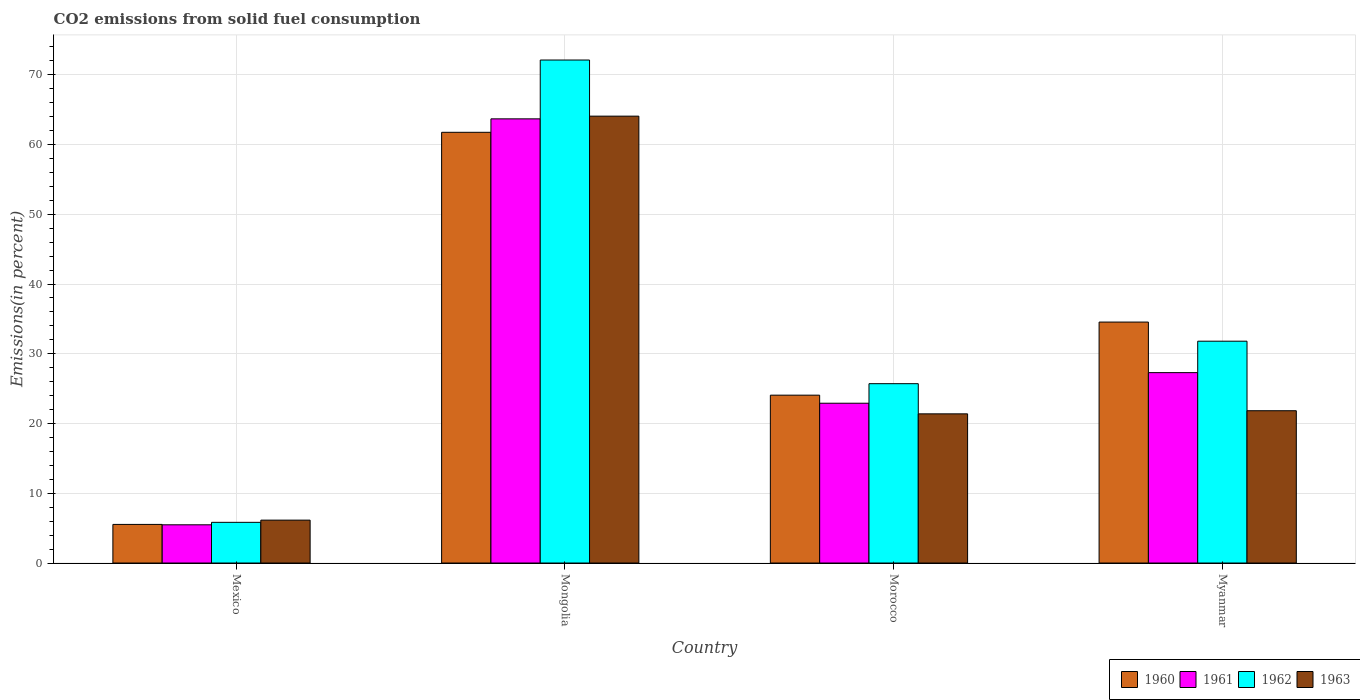Are the number of bars per tick equal to the number of legend labels?
Ensure brevity in your answer.  Yes. Are the number of bars on each tick of the X-axis equal?
Offer a terse response. Yes. How many bars are there on the 2nd tick from the left?
Keep it short and to the point. 4. What is the label of the 4th group of bars from the left?
Provide a succinct answer. Myanmar. What is the total CO2 emitted in 1960 in Mexico?
Provide a succinct answer. 5.54. Across all countries, what is the maximum total CO2 emitted in 1961?
Your answer should be very brief. 63.68. Across all countries, what is the minimum total CO2 emitted in 1961?
Provide a short and direct response. 5.48. In which country was the total CO2 emitted in 1963 maximum?
Ensure brevity in your answer.  Mongolia. In which country was the total CO2 emitted in 1960 minimum?
Ensure brevity in your answer.  Mexico. What is the total total CO2 emitted in 1961 in the graph?
Your response must be concise. 119.38. What is the difference between the total CO2 emitted in 1960 in Mongolia and that in Myanmar?
Provide a short and direct response. 27.21. What is the difference between the total CO2 emitted in 1961 in Mexico and the total CO2 emitted in 1960 in Morocco?
Provide a succinct answer. -18.59. What is the average total CO2 emitted in 1960 per country?
Give a very brief answer. 31.48. What is the difference between the total CO2 emitted of/in 1960 and total CO2 emitted of/in 1963 in Mongolia?
Make the answer very short. -2.32. What is the ratio of the total CO2 emitted in 1962 in Mexico to that in Morocco?
Provide a short and direct response. 0.23. Is the total CO2 emitted in 1960 in Mongolia less than that in Morocco?
Offer a very short reply. No. What is the difference between the highest and the second highest total CO2 emitted in 1963?
Keep it short and to the point. 42.68. What is the difference between the highest and the lowest total CO2 emitted in 1960?
Provide a succinct answer. 56.22. In how many countries, is the total CO2 emitted in 1961 greater than the average total CO2 emitted in 1961 taken over all countries?
Your answer should be compact. 1. Is it the case that in every country, the sum of the total CO2 emitted in 1961 and total CO2 emitted in 1963 is greater than the sum of total CO2 emitted in 1962 and total CO2 emitted in 1960?
Offer a terse response. No. What does the 4th bar from the left in Mongolia represents?
Make the answer very short. 1963. Are all the bars in the graph horizontal?
Keep it short and to the point. No. What is the difference between two consecutive major ticks on the Y-axis?
Your answer should be compact. 10. Does the graph contain any zero values?
Offer a terse response. No. How many legend labels are there?
Make the answer very short. 4. How are the legend labels stacked?
Give a very brief answer. Horizontal. What is the title of the graph?
Provide a succinct answer. CO2 emissions from solid fuel consumption. What is the label or title of the Y-axis?
Provide a short and direct response. Emissions(in percent). What is the Emissions(in percent) of 1960 in Mexico?
Give a very brief answer. 5.54. What is the Emissions(in percent) in 1961 in Mexico?
Your response must be concise. 5.48. What is the Emissions(in percent) of 1962 in Mexico?
Ensure brevity in your answer.  5.83. What is the Emissions(in percent) in 1963 in Mexico?
Provide a short and direct response. 6.15. What is the Emissions(in percent) in 1960 in Mongolia?
Offer a terse response. 61.76. What is the Emissions(in percent) in 1961 in Mongolia?
Keep it short and to the point. 63.68. What is the Emissions(in percent) in 1962 in Mongolia?
Provide a succinct answer. 72.12. What is the Emissions(in percent) in 1963 in Mongolia?
Ensure brevity in your answer.  64.07. What is the Emissions(in percent) in 1960 in Morocco?
Your answer should be compact. 24.07. What is the Emissions(in percent) of 1961 in Morocco?
Your response must be concise. 22.91. What is the Emissions(in percent) of 1962 in Morocco?
Your answer should be compact. 25.71. What is the Emissions(in percent) in 1963 in Morocco?
Your response must be concise. 21.39. What is the Emissions(in percent) in 1960 in Myanmar?
Offer a very short reply. 34.55. What is the Emissions(in percent) in 1961 in Myanmar?
Keep it short and to the point. 27.3. What is the Emissions(in percent) of 1962 in Myanmar?
Make the answer very short. 31.81. What is the Emissions(in percent) in 1963 in Myanmar?
Give a very brief answer. 21.84. Across all countries, what is the maximum Emissions(in percent) in 1960?
Provide a succinct answer. 61.76. Across all countries, what is the maximum Emissions(in percent) in 1961?
Make the answer very short. 63.68. Across all countries, what is the maximum Emissions(in percent) of 1962?
Make the answer very short. 72.12. Across all countries, what is the maximum Emissions(in percent) of 1963?
Offer a terse response. 64.07. Across all countries, what is the minimum Emissions(in percent) of 1960?
Keep it short and to the point. 5.54. Across all countries, what is the minimum Emissions(in percent) in 1961?
Keep it short and to the point. 5.48. Across all countries, what is the minimum Emissions(in percent) in 1962?
Offer a very short reply. 5.83. Across all countries, what is the minimum Emissions(in percent) of 1963?
Ensure brevity in your answer.  6.15. What is the total Emissions(in percent) in 1960 in the graph?
Provide a short and direct response. 125.91. What is the total Emissions(in percent) of 1961 in the graph?
Provide a succinct answer. 119.38. What is the total Emissions(in percent) in 1962 in the graph?
Provide a short and direct response. 135.47. What is the total Emissions(in percent) in 1963 in the graph?
Give a very brief answer. 113.45. What is the difference between the Emissions(in percent) of 1960 in Mexico and that in Mongolia?
Give a very brief answer. -56.22. What is the difference between the Emissions(in percent) in 1961 in Mexico and that in Mongolia?
Give a very brief answer. -58.2. What is the difference between the Emissions(in percent) of 1962 in Mexico and that in Mongolia?
Ensure brevity in your answer.  -66.29. What is the difference between the Emissions(in percent) of 1963 in Mexico and that in Mongolia?
Offer a terse response. -57.92. What is the difference between the Emissions(in percent) of 1960 in Mexico and that in Morocco?
Provide a succinct answer. -18.53. What is the difference between the Emissions(in percent) of 1961 in Mexico and that in Morocco?
Offer a terse response. -17.43. What is the difference between the Emissions(in percent) of 1962 in Mexico and that in Morocco?
Make the answer very short. -19.88. What is the difference between the Emissions(in percent) in 1963 in Mexico and that in Morocco?
Provide a succinct answer. -15.24. What is the difference between the Emissions(in percent) of 1960 in Mexico and that in Myanmar?
Offer a very short reply. -29.01. What is the difference between the Emissions(in percent) in 1961 in Mexico and that in Myanmar?
Give a very brief answer. -21.82. What is the difference between the Emissions(in percent) in 1962 in Mexico and that in Myanmar?
Offer a terse response. -25.97. What is the difference between the Emissions(in percent) of 1963 in Mexico and that in Myanmar?
Give a very brief answer. -15.69. What is the difference between the Emissions(in percent) in 1960 in Mongolia and that in Morocco?
Your response must be concise. 37.69. What is the difference between the Emissions(in percent) in 1961 in Mongolia and that in Morocco?
Keep it short and to the point. 40.77. What is the difference between the Emissions(in percent) of 1962 in Mongolia and that in Morocco?
Your answer should be compact. 46.4. What is the difference between the Emissions(in percent) in 1963 in Mongolia and that in Morocco?
Give a very brief answer. 42.68. What is the difference between the Emissions(in percent) in 1960 in Mongolia and that in Myanmar?
Provide a short and direct response. 27.21. What is the difference between the Emissions(in percent) in 1961 in Mongolia and that in Myanmar?
Make the answer very short. 36.39. What is the difference between the Emissions(in percent) in 1962 in Mongolia and that in Myanmar?
Keep it short and to the point. 40.31. What is the difference between the Emissions(in percent) of 1963 in Mongolia and that in Myanmar?
Offer a very short reply. 42.24. What is the difference between the Emissions(in percent) of 1960 in Morocco and that in Myanmar?
Make the answer very short. -10.48. What is the difference between the Emissions(in percent) of 1961 in Morocco and that in Myanmar?
Your answer should be very brief. -4.39. What is the difference between the Emissions(in percent) in 1962 in Morocco and that in Myanmar?
Provide a succinct answer. -6.09. What is the difference between the Emissions(in percent) in 1963 in Morocco and that in Myanmar?
Your answer should be compact. -0.45. What is the difference between the Emissions(in percent) in 1960 in Mexico and the Emissions(in percent) in 1961 in Mongolia?
Make the answer very short. -58.15. What is the difference between the Emissions(in percent) of 1960 in Mexico and the Emissions(in percent) of 1962 in Mongolia?
Keep it short and to the point. -66.58. What is the difference between the Emissions(in percent) of 1960 in Mexico and the Emissions(in percent) of 1963 in Mongolia?
Offer a very short reply. -58.54. What is the difference between the Emissions(in percent) in 1961 in Mexico and the Emissions(in percent) in 1962 in Mongolia?
Offer a very short reply. -66.64. What is the difference between the Emissions(in percent) of 1961 in Mexico and the Emissions(in percent) of 1963 in Mongolia?
Offer a very short reply. -58.59. What is the difference between the Emissions(in percent) in 1962 in Mexico and the Emissions(in percent) in 1963 in Mongolia?
Your response must be concise. -58.24. What is the difference between the Emissions(in percent) of 1960 in Mexico and the Emissions(in percent) of 1961 in Morocco?
Your answer should be compact. -17.38. What is the difference between the Emissions(in percent) in 1960 in Mexico and the Emissions(in percent) in 1962 in Morocco?
Ensure brevity in your answer.  -20.18. What is the difference between the Emissions(in percent) of 1960 in Mexico and the Emissions(in percent) of 1963 in Morocco?
Give a very brief answer. -15.85. What is the difference between the Emissions(in percent) in 1961 in Mexico and the Emissions(in percent) in 1962 in Morocco?
Make the answer very short. -20.23. What is the difference between the Emissions(in percent) of 1961 in Mexico and the Emissions(in percent) of 1963 in Morocco?
Give a very brief answer. -15.91. What is the difference between the Emissions(in percent) in 1962 in Mexico and the Emissions(in percent) in 1963 in Morocco?
Offer a very short reply. -15.56. What is the difference between the Emissions(in percent) of 1960 in Mexico and the Emissions(in percent) of 1961 in Myanmar?
Make the answer very short. -21.76. What is the difference between the Emissions(in percent) of 1960 in Mexico and the Emissions(in percent) of 1962 in Myanmar?
Provide a short and direct response. -26.27. What is the difference between the Emissions(in percent) in 1960 in Mexico and the Emissions(in percent) in 1963 in Myanmar?
Keep it short and to the point. -16.3. What is the difference between the Emissions(in percent) in 1961 in Mexico and the Emissions(in percent) in 1962 in Myanmar?
Your answer should be very brief. -26.33. What is the difference between the Emissions(in percent) in 1961 in Mexico and the Emissions(in percent) in 1963 in Myanmar?
Make the answer very short. -16.36. What is the difference between the Emissions(in percent) in 1962 in Mexico and the Emissions(in percent) in 1963 in Myanmar?
Provide a succinct answer. -16. What is the difference between the Emissions(in percent) in 1960 in Mongolia and the Emissions(in percent) in 1961 in Morocco?
Your response must be concise. 38.84. What is the difference between the Emissions(in percent) in 1960 in Mongolia and the Emissions(in percent) in 1962 in Morocco?
Offer a very short reply. 36.04. What is the difference between the Emissions(in percent) in 1960 in Mongolia and the Emissions(in percent) in 1963 in Morocco?
Offer a terse response. 40.37. What is the difference between the Emissions(in percent) in 1961 in Mongolia and the Emissions(in percent) in 1962 in Morocco?
Ensure brevity in your answer.  37.97. What is the difference between the Emissions(in percent) of 1961 in Mongolia and the Emissions(in percent) of 1963 in Morocco?
Offer a terse response. 42.3. What is the difference between the Emissions(in percent) of 1962 in Mongolia and the Emissions(in percent) of 1963 in Morocco?
Keep it short and to the point. 50.73. What is the difference between the Emissions(in percent) in 1960 in Mongolia and the Emissions(in percent) in 1961 in Myanmar?
Ensure brevity in your answer.  34.46. What is the difference between the Emissions(in percent) in 1960 in Mongolia and the Emissions(in percent) in 1962 in Myanmar?
Offer a very short reply. 29.95. What is the difference between the Emissions(in percent) in 1960 in Mongolia and the Emissions(in percent) in 1963 in Myanmar?
Your answer should be very brief. 39.92. What is the difference between the Emissions(in percent) in 1961 in Mongolia and the Emissions(in percent) in 1962 in Myanmar?
Provide a short and direct response. 31.88. What is the difference between the Emissions(in percent) in 1961 in Mongolia and the Emissions(in percent) in 1963 in Myanmar?
Provide a succinct answer. 41.85. What is the difference between the Emissions(in percent) in 1962 in Mongolia and the Emissions(in percent) in 1963 in Myanmar?
Keep it short and to the point. 50.28. What is the difference between the Emissions(in percent) of 1960 in Morocco and the Emissions(in percent) of 1961 in Myanmar?
Your answer should be compact. -3.23. What is the difference between the Emissions(in percent) in 1960 in Morocco and the Emissions(in percent) in 1962 in Myanmar?
Keep it short and to the point. -7.74. What is the difference between the Emissions(in percent) in 1960 in Morocco and the Emissions(in percent) in 1963 in Myanmar?
Your answer should be compact. 2.23. What is the difference between the Emissions(in percent) of 1961 in Morocco and the Emissions(in percent) of 1962 in Myanmar?
Your answer should be very brief. -8.89. What is the difference between the Emissions(in percent) in 1961 in Morocco and the Emissions(in percent) in 1963 in Myanmar?
Provide a succinct answer. 1.08. What is the difference between the Emissions(in percent) in 1962 in Morocco and the Emissions(in percent) in 1963 in Myanmar?
Your answer should be very brief. 3.88. What is the average Emissions(in percent) in 1960 per country?
Provide a succinct answer. 31.48. What is the average Emissions(in percent) in 1961 per country?
Offer a very short reply. 29.84. What is the average Emissions(in percent) of 1962 per country?
Your response must be concise. 33.87. What is the average Emissions(in percent) of 1963 per country?
Give a very brief answer. 28.36. What is the difference between the Emissions(in percent) of 1960 and Emissions(in percent) of 1961 in Mexico?
Provide a succinct answer. 0.06. What is the difference between the Emissions(in percent) of 1960 and Emissions(in percent) of 1962 in Mexico?
Your answer should be very brief. -0.3. What is the difference between the Emissions(in percent) of 1960 and Emissions(in percent) of 1963 in Mexico?
Ensure brevity in your answer.  -0.61. What is the difference between the Emissions(in percent) of 1961 and Emissions(in percent) of 1962 in Mexico?
Ensure brevity in your answer.  -0.35. What is the difference between the Emissions(in percent) in 1961 and Emissions(in percent) in 1963 in Mexico?
Your answer should be very brief. -0.67. What is the difference between the Emissions(in percent) in 1962 and Emissions(in percent) in 1963 in Mexico?
Offer a very short reply. -0.32. What is the difference between the Emissions(in percent) of 1960 and Emissions(in percent) of 1961 in Mongolia?
Offer a very short reply. -1.93. What is the difference between the Emissions(in percent) of 1960 and Emissions(in percent) of 1962 in Mongolia?
Ensure brevity in your answer.  -10.36. What is the difference between the Emissions(in percent) in 1960 and Emissions(in percent) in 1963 in Mongolia?
Provide a succinct answer. -2.32. What is the difference between the Emissions(in percent) of 1961 and Emissions(in percent) of 1962 in Mongolia?
Your answer should be very brief. -8.43. What is the difference between the Emissions(in percent) in 1961 and Emissions(in percent) in 1963 in Mongolia?
Offer a very short reply. -0.39. What is the difference between the Emissions(in percent) in 1962 and Emissions(in percent) in 1963 in Mongolia?
Ensure brevity in your answer.  8.05. What is the difference between the Emissions(in percent) of 1960 and Emissions(in percent) of 1961 in Morocco?
Your answer should be compact. 1.16. What is the difference between the Emissions(in percent) in 1960 and Emissions(in percent) in 1962 in Morocco?
Ensure brevity in your answer.  -1.65. What is the difference between the Emissions(in percent) of 1960 and Emissions(in percent) of 1963 in Morocco?
Offer a terse response. 2.68. What is the difference between the Emissions(in percent) of 1961 and Emissions(in percent) of 1962 in Morocco?
Give a very brief answer. -2.8. What is the difference between the Emissions(in percent) of 1961 and Emissions(in percent) of 1963 in Morocco?
Provide a short and direct response. 1.52. What is the difference between the Emissions(in percent) in 1962 and Emissions(in percent) in 1963 in Morocco?
Make the answer very short. 4.33. What is the difference between the Emissions(in percent) of 1960 and Emissions(in percent) of 1961 in Myanmar?
Keep it short and to the point. 7.25. What is the difference between the Emissions(in percent) of 1960 and Emissions(in percent) of 1962 in Myanmar?
Offer a terse response. 2.74. What is the difference between the Emissions(in percent) of 1960 and Emissions(in percent) of 1963 in Myanmar?
Offer a terse response. 12.71. What is the difference between the Emissions(in percent) in 1961 and Emissions(in percent) in 1962 in Myanmar?
Keep it short and to the point. -4.51. What is the difference between the Emissions(in percent) of 1961 and Emissions(in percent) of 1963 in Myanmar?
Give a very brief answer. 5.46. What is the difference between the Emissions(in percent) in 1962 and Emissions(in percent) in 1963 in Myanmar?
Your answer should be compact. 9.97. What is the ratio of the Emissions(in percent) in 1960 in Mexico to that in Mongolia?
Your response must be concise. 0.09. What is the ratio of the Emissions(in percent) in 1961 in Mexico to that in Mongolia?
Your response must be concise. 0.09. What is the ratio of the Emissions(in percent) in 1962 in Mexico to that in Mongolia?
Give a very brief answer. 0.08. What is the ratio of the Emissions(in percent) of 1963 in Mexico to that in Mongolia?
Offer a terse response. 0.1. What is the ratio of the Emissions(in percent) in 1960 in Mexico to that in Morocco?
Offer a very short reply. 0.23. What is the ratio of the Emissions(in percent) in 1961 in Mexico to that in Morocco?
Your answer should be compact. 0.24. What is the ratio of the Emissions(in percent) of 1962 in Mexico to that in Morocco?
Ensure brevity in your answer.  0.23. What is the ratio of the Emissions(in percent) of 1963 in Mexico to that in Morocco?
Provide a succinct answer. 0.29. What is the ratio of the Emissions(in percent) of 1960 in Mexico to that in Myanmar?
Your response must be concise. 0.16. What is the ratio of the Emissions(in percent) in 1961 in Mexico to that in Myanmar?
Provide a short and direct response. 0.2. What is the ratio of the Emissions(in percent) of 1962 in Mexico to that in Myanmar?
Your response must be concise. 0.18. What is the ratio of the Emissions(in percent) in 1963 in Mexico to that in Myanmar?
Offer a very short reply. 0.28. What is the ratio of the Emissions(in percent) of 1960 in Mongolia to that in Morocco?
Keep it short and to the point. 2.57. What is the ratio of the Emissions(in percent) of 1961 in Mongolia to that in Morocco?
Give a very brief answer. 2.78. What is the ratio of the Emissions(in percent) of 1962 in Mongolia to that in Morocco?
Offer a terse response. 2.8. What is the ratio of the Emissions(in percent) in 1963 in Mongolia to that in Morocco?
Keep it short and to the point. 3. What is the ratio of the Emissions(in percent) of 1960 in Mongolia to that in Myanmar?
Make the answer very short. 1.79. What is the ratio of the Emissions(in percent) of 1961 in Mongolia to that in Myanmar?
Offer a terse response. 2.33. What is the ratio of the Emissions(in percent) in 1962 in Mongolia to that in Myanmar?
Make the answer very short. 2.27. What is the ratio of the Emissions(in percent) of 1963 in Mongolia to that in Myanmar?
Make the answer very short. 2.93. What is the ratio of the Emissions(in percent) in 1960 in Morocco to that in Myanmar?
Your response must be concise. 0.7. What is the ratio of the Emissions(in percent) in 1961 in Morocco to that in Myanmar?
Keep it short and to the point. 0.84. What is the ratio of the Emissions(in percent) of 1962 in Morocco to that in Myanmar?
Give a very brief answer. 0.81. What is the ratio of the Emissions(in percent) of 1963 in Morocco to that in Myanmar?
Make the answer very short. 0.98. What is the difference between the highest and the second highest Emissions(in percent) of 1960?
Your answer should be very brief. 27.21. What is the difference between the highest and the second highest Emissions(in percent) of 1961?
Offer a terse response. 36.39. What is the difference between the highest and the second highest Emissions(in percent) of 1962?
Your answer should be compact. 40.31. What is the difference between the highest and the second highest Emissions(in percent) in 1963?
Ensure brevity in your answer.  42.24. What is the difference between the highest and the lowest Emissions(in percent) in 1960?
Make the answer very short. 56.22. What is the difference between the highest and the lowest Emissions(in percent) in 1961?
Make the answer very short. 58.2. What is the difference between the highest and the lowest Emissions(in percent) in 1962?
Your response must be concise. 66.29. What is the difference between the highest and the lowest Emissions(in percent) of 1963?
Keep it short and to the point. 57.92. 